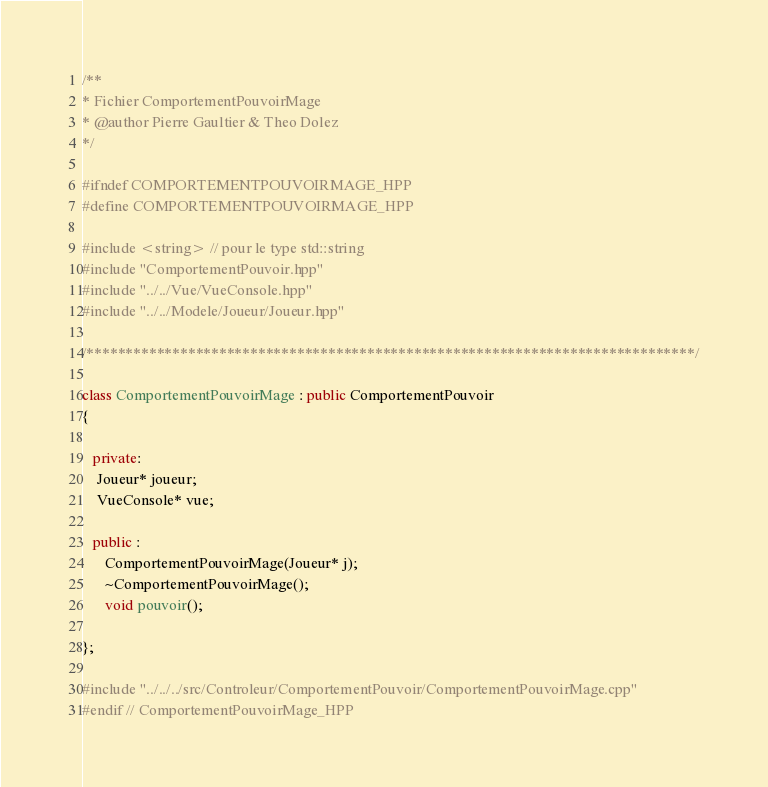Convert code to text. <code><loc_0><loc_0><loc_500><loc_500><_C++_>/**
* Fichier ComportementPouvoirMage
* @author Pierre Gaultier & Theo Dolez
*/

#ifndef COMPORTEMENTPOUVOIRMAGE_HPP
#define COMPORTEMENTPOUVOIRMAGE_HPP

#include <string> // pour le type std::string
#include "ComportementPouvoir.hpp"
#include "../../Vue/VueConsole.hpp"
#include "../../Modele/Joueur/Joueur.hpp"

/******************************************************************************/

class ComportementPouvoirMage : public ComportementPouvoir
{

   private:
	Joueur* joueur;
	VueConsole* vue;

   public :
	  ComportementPouvoirMage(Joueur* j);
	  ~ComportementPouvoirMage();
	  void pouvoir();
	
};

#include "../../../src/Controleur/ComportementPouvoir/ComportementPouvoirMage.cpp"
#endif // ComportementPouvoirMage_HPP
</code> 